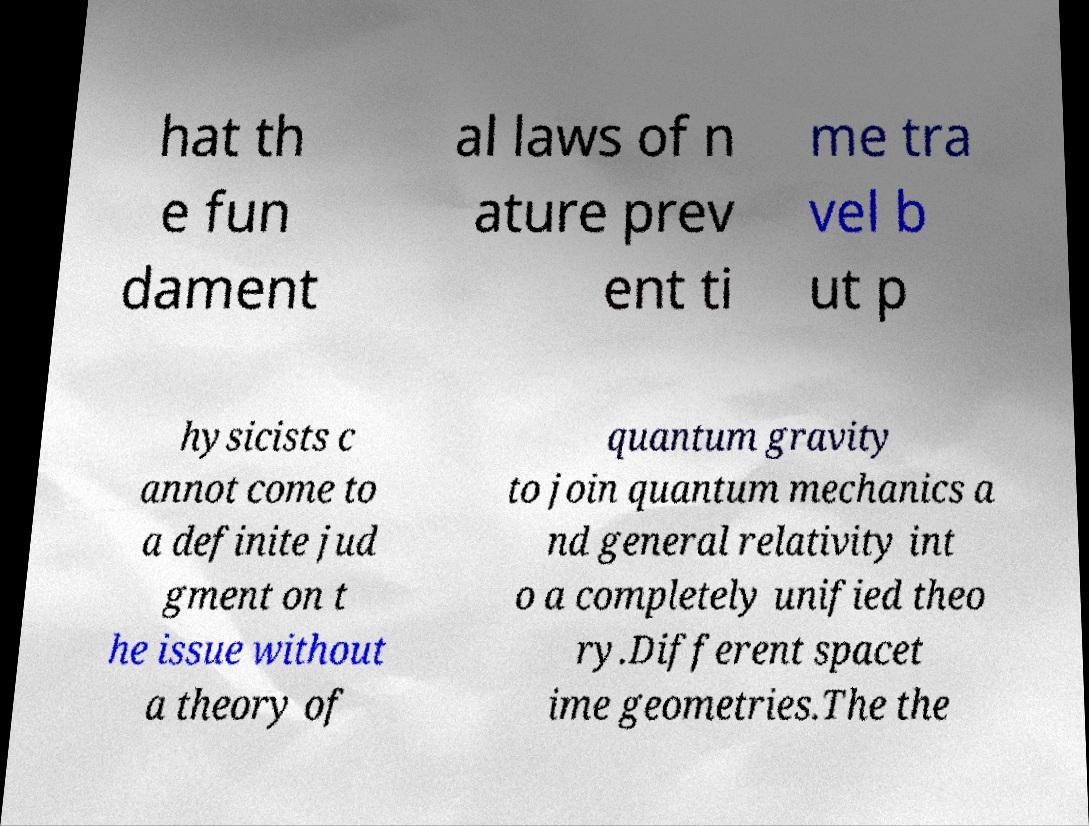Please read and relay the text visible in this image. What does it say? hat th e fun dament al laws of n ature prev ent ti me tra vel b ut p hysicists c annot come to a definite jud gment on t he issue without a theory of quantum gravity to join quantum mechanics a nd general relativity int o a completely unified theo ry.Different spacet ime geometries.The the 